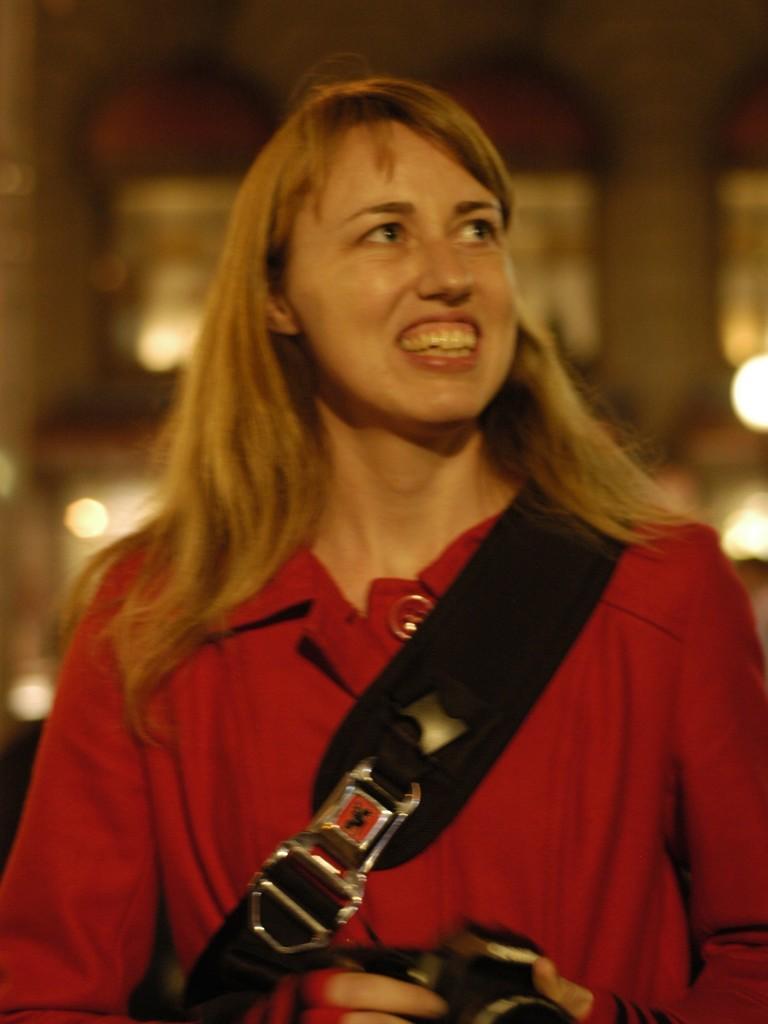Can you describe this image briefly? In this image, we can see a person holding an object and standing. We can see the blurred background. 